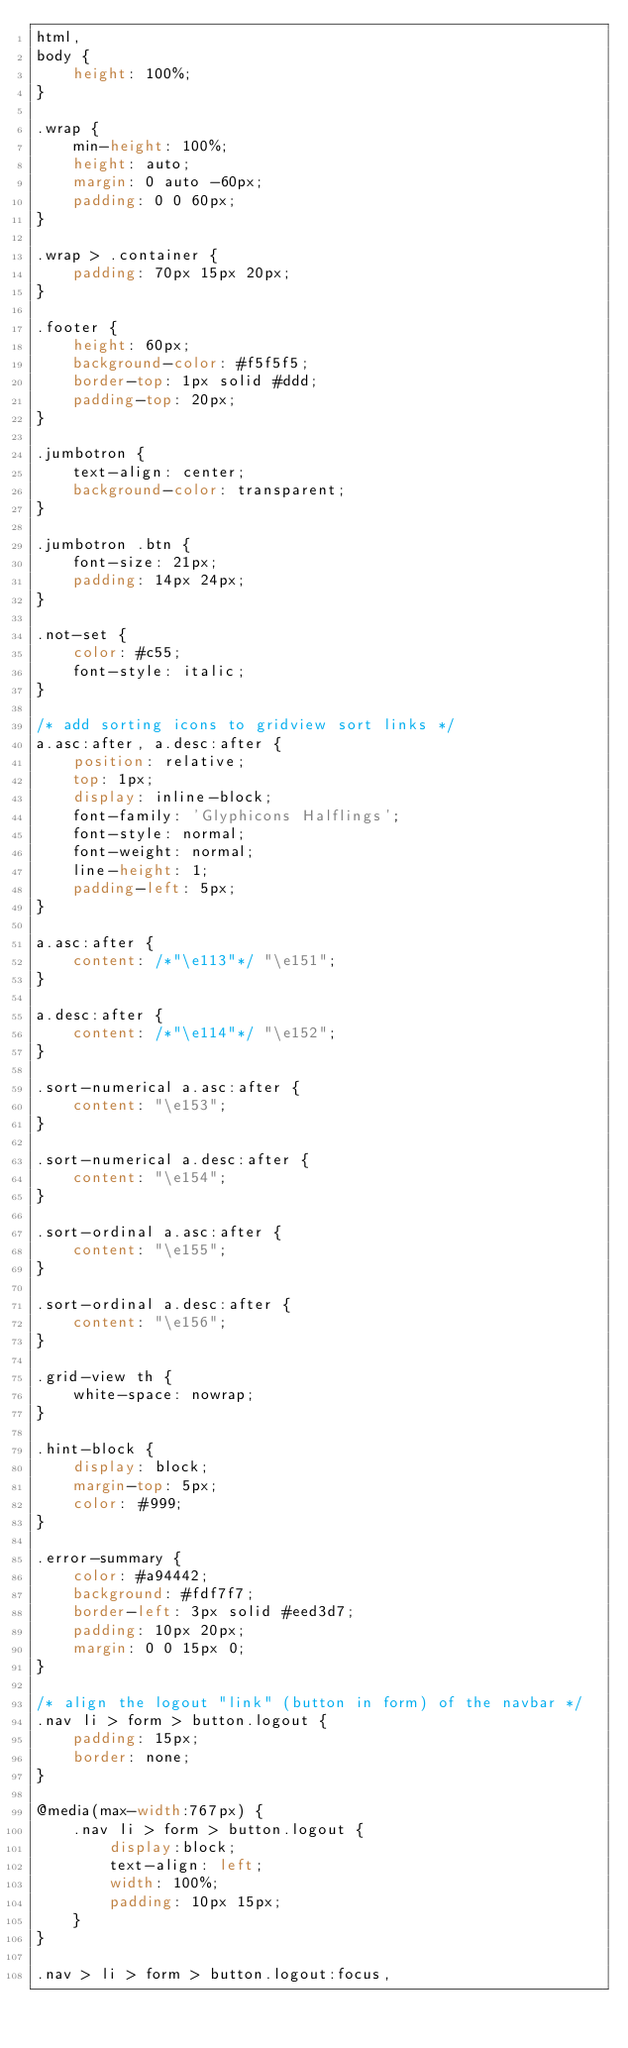Convert code to text. <code><loc_0><loc_0><loc_500><loc_500><_CSS_>html,
body {
    height: 100%;
}

.wrap {
    min-height: 100%;
    height: auto;
    margin: 0 auto -60px;
    padding: 0 0 60px;
}

.wrap > .container {
    padding: 70px 15px 20px;
}

.footer {
    height: 60px;
    background-color: #f5f5f5;
    border-top: 1px solid #ddd;
    padding-top: 20px;
}

.jumbotron {
    text-align: center;
    background-color: transparent;
}

.jumbotron .btn {
    font-size: 21px;
    padding: 14px 24px;
}

.not-set {
    color: #c55;
    font-style: italic;
}

/* add sorting icons to gridview sort links */
a.asc:after, a.desc:after {
    position: relative;
    top: 1px;
    display: inline-block;
    font-family: 'Glyphicons Halflings';
    font-style: normal;
    font-weight: normal;
    line-height: 1;
    padding-left: 5px;
}

a.asc:after {
    content: /*"\e113"*/ "\e151";
}

a.desc:after {
    content: /*"\e114"*/ "\e152";
}

.sort-numerical a.asc:after {
    content: "\e153";
}

.sort-numerical a.desc:after {
    content: "\e154";
}

.sort-ordinal a.asc:after {
    content: "\e155";
}

.sort-ordinal a.desc:after {
    content: "\e156";
}

.grid-view th {
    white-space: nowrap;
}

.hint-block {
    display: block;
    margin-top: 5px;
    color: #999;
}

.error-summary {
    color: #a94442;
    background: #fdf7f7;
    border-left: 3px solid #eed3d7;
    padding: 10px 20px;
    margin: 0 0 15px 0;
}

/* align the logout "link" (button in form) of the navbar */
.nav li > form > button.logout {
    padding: 15px;
    border: none;
}

@media(max-width:767px) {
    .nav li > form > button.logout {
        display:block;
        text-align: left;
        width: 100%;
        padding: 10px 15px;
    }
}

.nav > li > form > button.logout:focus,</code> 